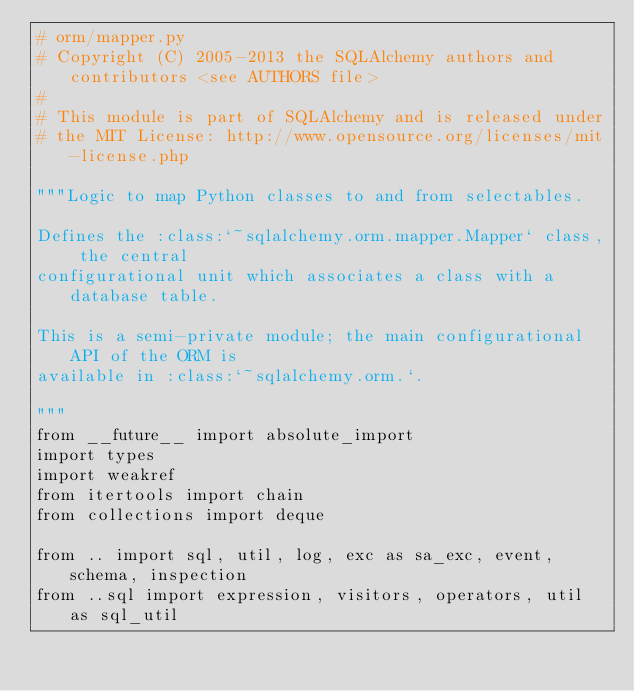<code> <loc_0><loc_0><loc_500><loc_500><_Python_># orm/mapper.py
# Copyright (C) 2005-2013 the SQLAlchemy authors and contributors <see AUTHORS file>
#
# This module is part of SQLAlchemy and is released under
# the MIT License: http://www.opensource.org/licenses/mit-license.php

"""Logic to map Python classes to and from selectables.

Defines the :class:`~sqlalchemy.orm.mapper.Mapper` class, the central
configurational unit which associates a class with a database table.

This is a semi-private module; the main configurational API of the ORM is
available in :class:`~sqlalchemy.orm.`.

"""
from __future__ import absolute_import
import types
import weakref
from itertools import chain
from collections import deque

from .. import sql, util, log, exc as sa_exc, event, schema, inspection
from ..sql import expression, visitors, operators, util as sql_util</code> 